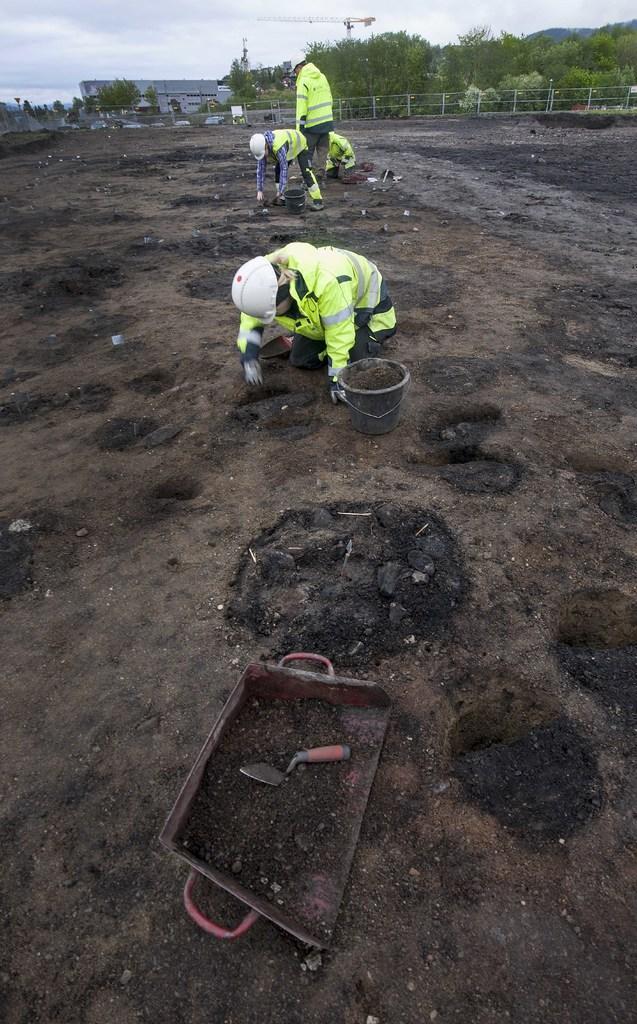Could you give a brief overview of what you see in this image? In the picture we can see a black muddy path on it, we can see some persons are searching something and far away from it, we can see a railing and behind it, we can see trees and beside it we can see some house building and in the background we can see a sky with clouds. 